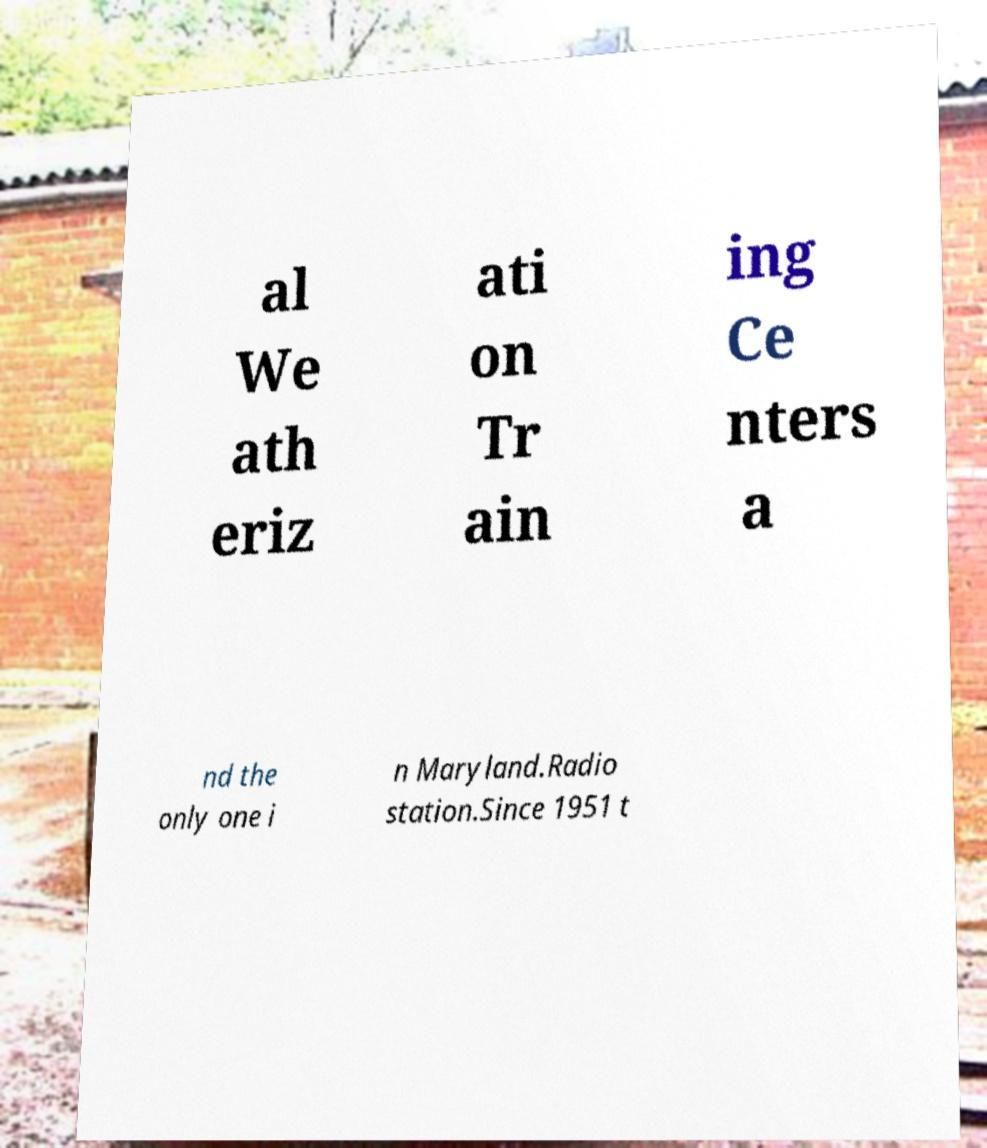What messages or text are displayed in this image? I need them in a readable, typed format. al We ath eriz ati on Tr ain ing Ce nters a nd the only one i n Maryland.Radio station.Since 1951 t 